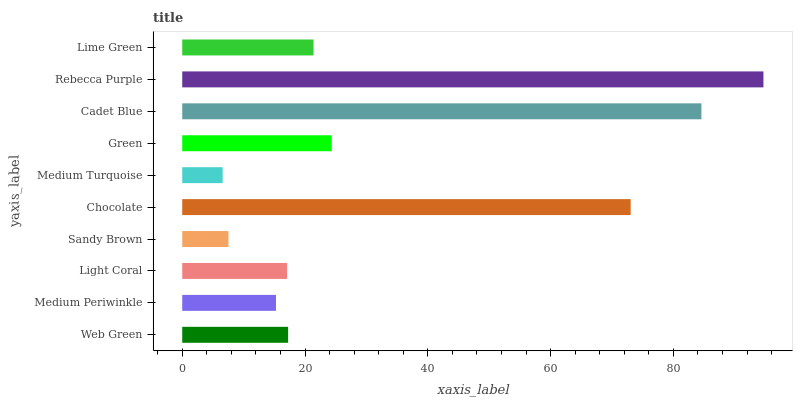Is Medium Turquoise the minimum?
Answer yes or no. Yes. Is Rebecca Purple the maximum?
Answer yes or no. Yes. Is Medium Periwinkle the minimum?
Answer yes or no. No. Is Medium Periwinkle the maximum?
Answer yes or no. No. Is Web Green greater than Medium Periwinkle?
Answer yes or no. Yes. Is Medium Periwinkle less than Web Green?
Answer yes or no. Yes. Is Medium Periwinkle greater than Web Green?
Answer yes or no. No. Is Web Green less than Medium Periwinkle?
Answer yes or no. No. Is Lime Green the high median?
Answer yes or no. Yes. Is Web Green the low median?
Answer yes or no. Yes. Is Sandy Brown the high median?
Answer yes or no. No. Is Sandy Brown the low median?
Answer yes or no. No. 